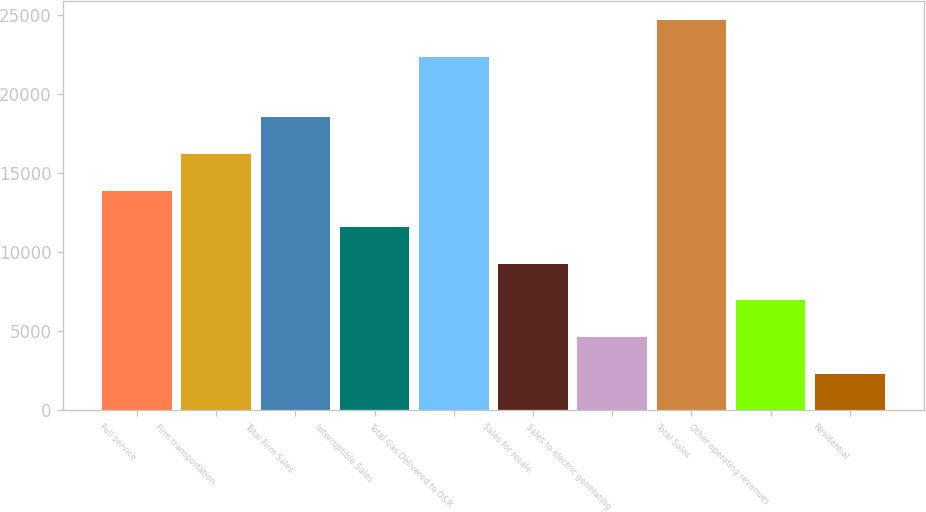Convert chart to OTSL. <chart><loc_0><loc_0><loc_500><loc_500><bar_chart><fcel>Full service<fcel>Firm transportation<fcel>Total Firm Sales<fcel>Interruptible Sales<fcel>Total Gas Delivered to O&R<fcel>Sales for resale<fcel>Sales to electric generating<fcel>Total Sales<fcel>Other operating revenues<fcel>Residential<nl><fcel>13911.6<fcel>16228.2<fcel>18544.8<fcel>11595<fcel>22370<fcel>9278.39<fcel>4645.19<fcel>24686.6<fcel>6961.79<fcel>2328.59<nl></chart> 